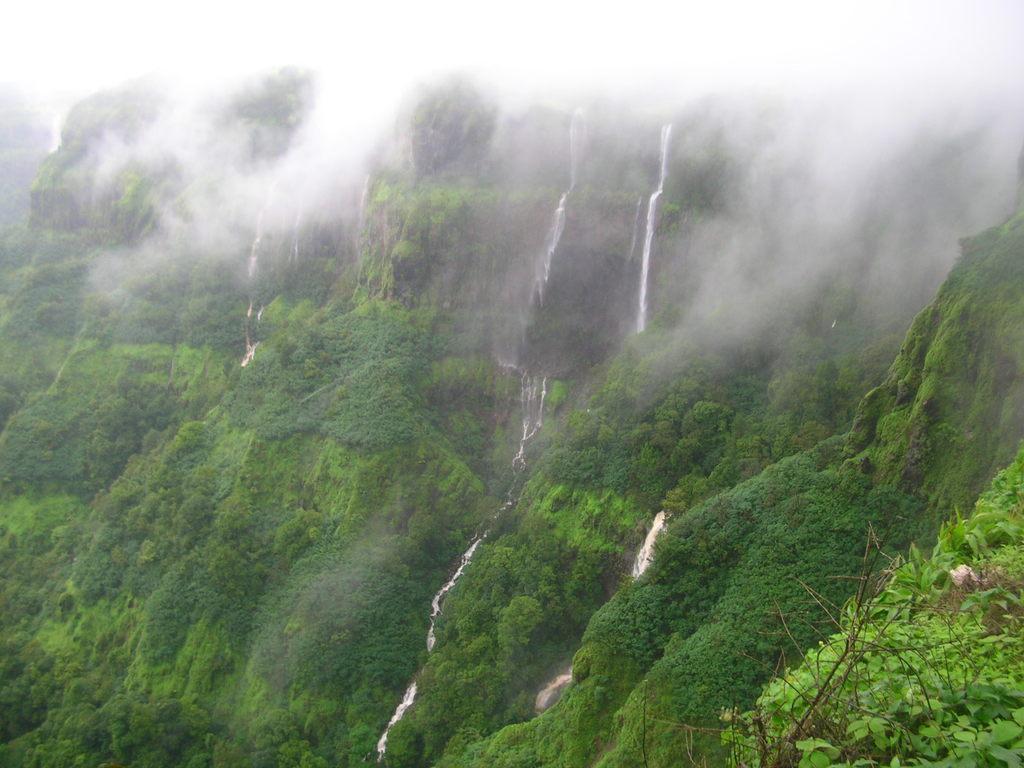Could you give a brief overview of what you see in this image? In this image we can see mountains with trees, water. At the top of the image there is fog. 